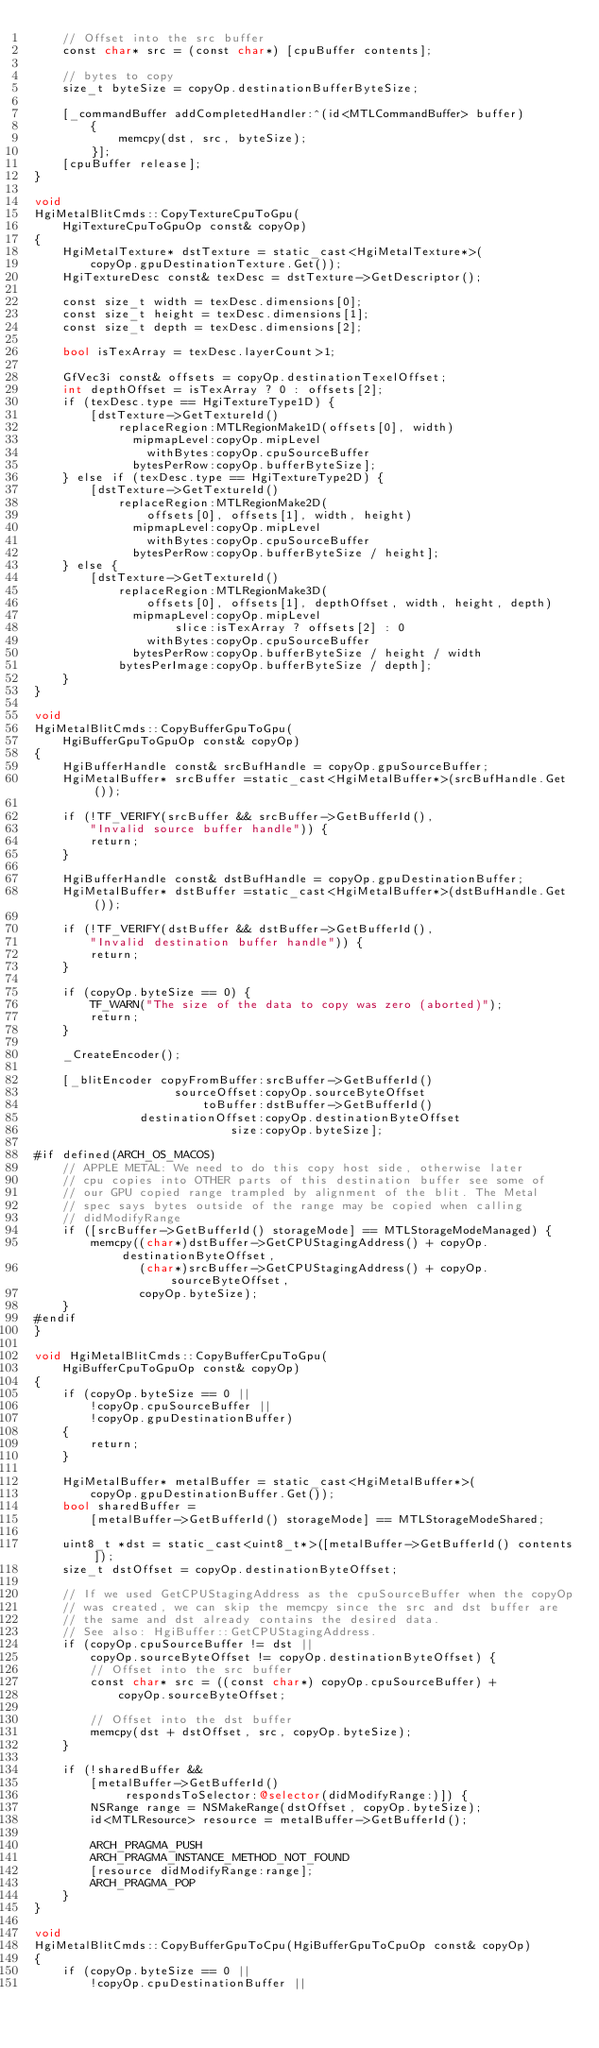Convert code to text. <code><loc_0><loc_0><loc_500><loc_500><_ObjectiveC_>    // Offset into the src buffer
    const char* src = (const char*) [cpuBuffer contents];

    // bytes to copy
    size_t byteSize = copyOp.destinationBufferByteSize;

    [_commandBuffer addCompletedHandler:^(id<MTLCommandBuffer> buffer)
        {
            memcpy(dst, src, byteSize);
        }];
    [cpuBuffer release];
}

void
HgiMetalBlitCmds::CopyTextureCpuToGpu(
    HgiTextureCpuToGpuOp const& copyOp)
{
    HgiMetalTexture* dstTexture = static_cast<HgiMetalTexture*>(
        copyOp.gpuDestinationTexture.Get());
    HgiTextureDesc const& texDesc = dstTexture->GetDescriptor();

    const size_t width = texDesc.dimensions[0];
    const size_t height = texDesc.dimensions[1];
    const size_t depth = texDesc.dimensions[2];

    bool isTexArray = texDesc.layerCount>1;

    GfVec3i const& offsets = copyOp.destinationTexelOffset;
    int depthOffset = isTexArray ? 0 : offsets[2];
    if (texDesc.type == HgiTextureType1D) {
        [dstTexture->GetTextureId()
            replaceRegion:MTLRegionMake1D(offsets[0], width)
              mipmapLevel:copyOp.mipLevel
                withBytes:copyOp.cpuSourceBuffer
              bytesPerRow:copyOp.bufferByteSize];
    } else if (texDesc.type == HgiTextureType2D) {
        [dstTexture->GetTextureId()
            replaceRegion:MTLRegionMake2D(
                offsets[0], offsets[1], width, height)
              mipmapLevel:copyOp.mipLevel
                withBytes:copyOp.cpuSourceBuffer
              bytesPerRow:copyOp.bufferByteSize / height];
    } else {
        [dstTexture->GetTextureId()
            replaceRegion:MTLRegionMake3D(
                offsets[0], offsets[1], depthOffset, width, height, depth)
              mipmapLevel:copyOp.mipLevel 
                    slice:isTexArray ? offsets[2] : 0
                withBytes:copyOp.cpuSourceBuffer
              bytesPerRow:copyOp.bufferByteSize / height / width
            bytesPerImage:copyOp.bufferByteSize / depth];
    }
}

void
HgiMetalBlitCmds::CopyBufferGpuToGpu(
    HgiBufferGpuToGpuOp const& copyOp)
{
    HgiBufferHandle const& srcBufHandle = copyOp.gpuSourceBuffer;
    HgiMetalBuffer* srcBuffer =static_cast<HgiMetalBuffer*>(srcBufHandle.Get());

    if (!TF_VERIFY(srcBuffer && srcBuffer->GetBufferId(),
        "Invalid source buffer handle")) {
        return;
    }

    HgiBufferHandle const& dstBufHandle = copyOp.gpuDestinationBuffer;
    HgiMetalBuffer* dstBuffer =static_cast<HgiMetalBuffer*>(dstBufHandle.Get());

    if (!TF_VERIFY(dstBuffer && dstBuffer->GetBufferId(),
        "Invalid destination buffer handle")) {
        return;
    }

    if (copyOp.byteSize == 0) {
        TF_WARN("The size of the data to copy was zero (aborted)");
        return;
    }

    _CreateEncoder();

    [_blitEncoder copyFromBuffer:srcBuffer->GetBufferId()
                    sourceOffset:copyOp.sourceByteOffset
                        toBuffer:dstBuffer->GetBufferId()
               destinationOffset:copyOp.destinationByteOffset
                            size:copyOp.byteSize];

#if defined(ARCH_OS_MACOS)
    // APPLE METAL: We need to do this copy host side, otherwise later
    // cpu copies into OTHER parts of this destination buffer see some of
    // our GPU copied range trampled by alignment of the blit. The Metal
    // spec says bytes outside of the range may be copied when calling
    // didModifyRange
    if ([srcBuffer->GetBufferId() storageMode] == MTLStorageModeManaged) {
        memcpy((char*)dstBuffer->GetCPUStagingAddress() + copyOp.destinationByteOffset,
               (char*)srcBuffer->GetCPUStagingAddress() + copyOp.sourceByteOffset,
               copyOp.byteSize);
    }
#endif
}

void HgiMetalBlitCmds::CopyBufferCpuToGpu(
    HgiBufferCpuToGpuOp const& copyOp)
{
    if (copyOp.byteSize == 0 ||
        !copyOp.cpuSourceBuffer ||
        !copyOp.gpuDestinationBuffer)
    {
        return;
    }

    HgiMetalBuffer* metalBuffer = static_cast<HgiMetalBuffer*>(
        copyOp.gpuDestinationBuffer.Get());
    bool sharedBuffer =
        [metalBuffer->GetBufferId() storageMode] == MTLStorageModeShared;

    uint8_t *dst = static_cast<uint8_t*>([metalBuffer->GetBufferId() contents]);
    size_t dstOffset = copyOp.destinationByteOffset;

    // If we used GetCPUStagingAddress as the cpuSourceBuffer when the copyOp
    // was created, we can skip the memcpy since the src and dst buffer are
    // the same and dst already contains the desired data.
    // See also: HgiBuffer::GetCPUStagingAddress.
    if (copyOp.cpuSourceBuffer != dst ||
        copyOp.sourceByteOffset != copyOp.destinationByteOffset) {
        // Offset into the src buffer
        const char* src = ((const char*) copyOp.cpuSourceBuffer) +
            copyOp.sourceByteOffset;

        // Offset into the dst buffer
        memcpy(dst + dstOffset, src, copyOp.byteSize);
    }

    if (!sharedBuffer &&
        [metalBuffer->GetBufferId()
             respondsToSelector:@selector(didModifyRange:)]) {
        NSRange range = NSMakeRange(dstOffset, copyOp.byteSize);
        id<MTLResource> resource = metalBuffer->GetBufferId();
        
        ARCH_PRAGMA_PUSH
        ARCH_PRAGMA_INSTANCE_METHOD_NOT_FOUND
        [resource didModifyRange:range];
        ARCH_PRAGMA_POP
    }
}

void
HgiMetalBlitCmds::CopyBufferGpuToCpu(HgiBufferGpuToCpuOp const& copyOp)
{
    if (copyOp.byteSize == 0 ||
        !copyOp.cpuDestinationBuffer ||</code> 